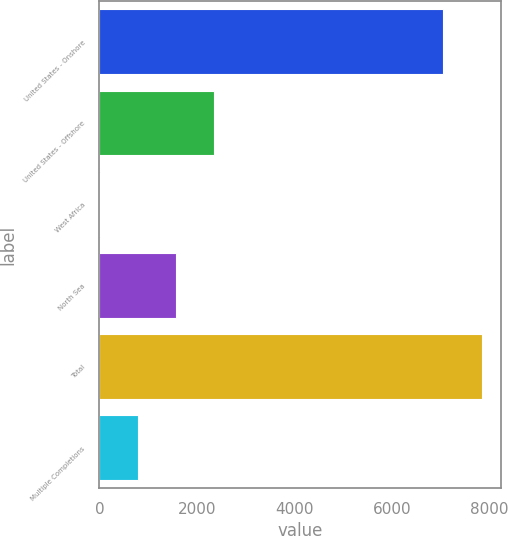Convert chart. <chart><loc_0><loc_0><loc_500><loc_500><bar_chart><fcel>United States - Onshore<fcel>United States - Offshore<fcel>West Africa<fcel>North Sea<fcel>Total<fcel>Multiple Completions<nl><fcel>7055<fcel>2354.8<fcel>1<fcel>1570.2<fcel>7847<fcel>785.6<nl></chart> 